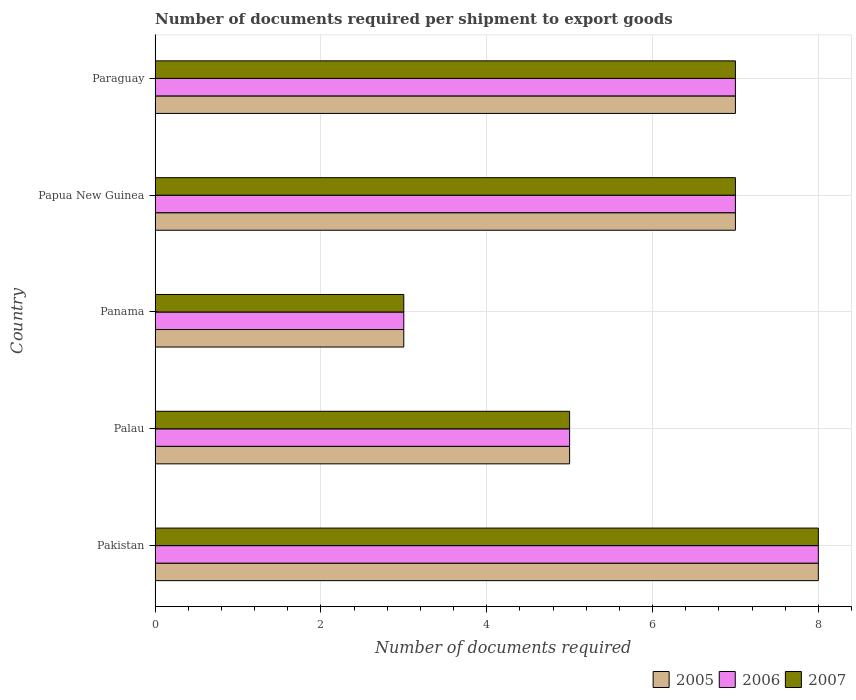How many groups of bars are there?
Your response must be concise. 5. Are the number of bars per tick equal to the number of legend labels?
Offer a very short reply. Yes. Are the number of bars on each tick of the Y-axis equal?
Your answer should be very brief. Yes. What is the label of the 1st group of bars from the top?
Make the answer very short. Paraguay. In how many cases, is the number of bars for a given country not equal to the number of legend labels?
Your answer should be very brief. 0. Across all countries, what is the maximum number of documents required per shipment to export goods in 2005?
Offer a terse response. 8. In which country was the number of documents required per shipment to export goods in 2006 minimum?
Give a very brief answer. Panama. What is the total number of documents required per shipment to export goods in 2005 in the graph?
Give a very brief answer. 30. What is the average number of documents required per shipment to export goods in 2006 per country?
Ensure brevity in your answer.  6. What is the difference between the number of documents required per shipment to export goods in 2005 and number of documents required per shipment to export goods in 2006 in Pakistan?
Make the answer very short. 0. In how many countries, is the number of documents required per shipment to export goods in 2007 greater than 6.8 ?
Offer a very short reply. 3. What is the ratio of the number of documents required per shipment to export goods in 2006 in Pakistan to that in Palau?
Your response must be concise. 1.6. Is the difference between the number of documents required per shipment to export goods in 2005 in Palau and Panama greater than the difference between the number of documents required per shipment to export goods in 2006 in Palau and Panama?
Keep it short and to the point. No. What is the difference between the highest and the second highest number of documents required per shipment to export goods in 2006?
Make the answer very short. 1. What is the difference between the highest and the lowest number of documents required per shipment to export goods in 2006?
Offer a terse response. 5. In how many countries, is the number of documents required per shipment to export goods in 2005 greater than the average number of documents required per shipment to export goods in 2005 taken over all countries?
Your answer should be compact. 3. Is the sum of the number of documents required per shipment to export goods in 2006 in Pakistan and Panama greater than the maximum number of documents required per shipment to export goods in 2007 across all countries?
Give a very brief answer. Yes. What does the 3rd bar from the top in Paraguay represents?
Ensure brevity in your answer.  2005. Is it the case that in every country, the sum of the number of documents required per shipment to export goods in 2005 and number of documents required per shipment to export goods in 2007 is greater than the number of documents required per shipment to export goods in 2006?
Provide a succinct answer. Yes. How many bars are there?
Your answer should be compact. 15. Are all the bars in the graph horizontal?
Your answer should be very brief. Yes. Does the graph contain grids?
Your answer should be compact. Yes. Where does the legend appear in the graph?
Your answer should be compact. Bottom right. What is the title of the graph?
Offer a terse response. Number of documents required per shipment to export goods. What is the label or title of the X-axis?
Your answer should be very brief. Number of documents required. What is the Number of documents required of 2006 in Palau?
Your answer should be very brief. 5. What is the Number of documents required in 2006 in Panama?
Your response must be concise. 3. What is the Number of documents required in 2006 in Papua New Guinea?
Your response must be concise. 7. Across all countries, what is the maximum Number of documents required of 2006?
Provide a short and direct response. 8. Across all countries, what is the maximum Number of documents required in 2007?
Ensure brevity in your answer.  8. What is the total Number of documents required of 2005 in the graph?
Give a very brief answer. 30. What is the total Number of documents required of 2006 in the graph?
Offer a very short reply. 30. What is the difference between the Number of documents required in 2005 in Pakistan and that in Palau?
Make the answer very short. 3. What is the difference between the Number of documents required in 2006 in Pakistan and that in Palau?
Offer a terse response. 3. What is the difference between the Number of documents required of 2007 in Pakistan and that in Palau?
Your answer should be very brief. 3. What is the difference between the Number of documents required of 2006 in Pakistan and that in Panama?
Offer a very short reply. 5. What is the difference between the Number of documents required of 2007 in Pakistan and that in Panama?
Provide a succinct answer. 5. What is the difference between the Number of documents required in 2005 in Pakistan and that in Papua New Guinea?
Offer a very short reply. 1. What is the difference between the Number of documents required of 2006 in Pakistan and that in Paraguay?
Your answer should be compact. 1. What is the difference between the Number of documents required in 2006 in Palau and that in Panama?
Keep it short and to the point. 2. What is the difference between the Number of documents required in 2005 in Palau and that in Papua New Guinea?
Provide a short and direct response. -2. What is the difference between the Number of documents required in 2006 in Palau and that in Papua New Guinea?
Offer a very short reply. -2. What is the difference between the Number of documents required of 2007 in Palau and that in Papua New Guinea?
Your answer should be very brief. -2. What is the difference between the Number of documents required of 2005 in Palau and that in Paraguay?
Offer a very short reply. -2. What is the difference between the Number of documents required in 2006 in Palau and that in Paraguay?
Make the answer very short. -2. What is the difference between the Number of documents required of 2007 in Palau and that in Paraguay?
Offer a very short reply. -2. What is the difference between the Number of documents required of 2006 in Panama and that in Papua New Guinea?
Keep it short and to the point. -4. What is the difference between the Number of documents required of 2005 in Panama and that in Paraguay?
Give a very brief answer. -4. What is the difference between the Number of documents required in 2006 in Panama and that in Paraguay?
Provide a succinct answer. -4. What is the difference between the Number of documents required in 2007 in Panama and that in Paraguay?
Provide a succinct answer. -4. What is the difference between the Number of documents required of 2005 in Papua New Guinea and that in Paraguay?
Ensure brevity in your answer.  0. What is the difference between the Number of documents required of 2006 in Papua New Guinea and that in Paraguay?
Offer a very short reply. 0. What is the difference between the Number of documents required in 2005 in Pakistan and the Number of documents required in 2007 in Panama?
Make the answer very short. 5. What is the difference between the Number of documents required of 2005 in Pakistan and the Number of documents required of 2007 in Papua New Guinea?
Offer a terse response. 1. What is the difference between the Number of documents required of 2006 in Pakistan and the Number of documents required of 2007 in Papua New Guinea?
Offer a very short reply. 1. What is the difference between the Number of documents required of 2005 in Pakistan and the Number of documents required of 2007 in Paraguay?
Your response must be concise. 1. What is the difference between the Number of documents required of 2005 in Palau and the Number of documents required of 2006 in Papua New Guinea?
Offer a very short reply. -2. What is the difference between the Number of documents required in 2006 in Palau and the Number of documents required in 2007 in Papua New Guinea?
Offer a very short reply. -2. What is the difference between the Number of documents required of 2005 in Panama and the Number of documents required of 2006 in Papua New Guinea?
Your response must be concise. -4. What is the difference between the Number of documents required of 2006 in Panama and the Number of documents required of 2007 in Papua New Guinea?
Provide a succinct answer. -4. What is the difference between the Number of documents required in 2005 in Panama and the Number of documents required in 2006 in Paraguay?
Make the answer very short. -4. What is the difference between the Number of documents required in 2005 in Panama and the Number of documents required in 2007 in Paraguay?
Provide a short and direct response. -4. What is the difference between the Number of documents required of 2005 in Papua New Guinea and the Number of documents required of 2007 in Paraguay?
Provide a short and direct response. 0. What is the average Number of documents required of 2005 per country?
Provide a succinct answer. 6. What is the average Number of documents required of 2006 per country?
Offer a terse response. 6. What is the average Number of documents required of 2007 per country?
Make the answer very short. 6. What is the difference between the Number of documents required of 2006 and Number of documents required of 2007 in Pakistan?
Ensure brevity in your answer.  0. What is the difference between the Number of documents required in 2005 and Number of documents required in 2006 in Palau?
Your response must be concise. 0. What is the difference between the Number of documents required of 2005 and Number of documents required of 2007 in Palau?
Your answer should be compact. 0. What is the difference between the Number of documents required of 2005 and Number of documents required of 2007 in Panama?
Your answer should be compact. 0. What is the difference between the Number of documents required of 2006 and Number of documents required of 2007 in Panama?
Ensure brevity in your answer.  0. What is the difference between the Number of documents required in 2005 and Number of documents required in 2007 in Papua New Guinea?
Keep it short and to the point. 0. What is the difference between the Number of documents required in 2006 and Number of documents required in 2007 in Papua New Guinea?
Keep it short and to the point. 0. What is the difference between the Number of documents required in 2006 and Number of documents required in 2007 in Paraguay?
Offer a very short reply. 0. What is the ratio of the Number of documents required in 2006 in Pakistan to that in Palau?
Offer a terse response. 1.6. What is the ratio of the Number of documents required in 2007 in Pakistan to that in Palau?
Provide a succinct answer. 1.6. What is the ratio of the Number of documents required in 2005 in Pakistan to that in Panama?
Your response must be concise. 2.67. What is the ratio of the Number of documents required in 2006 in Pakistan to that in Panama?
Offer a terse response. 2.67. What is the ratio of the Number of documents required in 2007 in Pakistan to that in Panama?
Keep it short and to the point. 2.67. What is the ratio of the Number of documents required of 2006 in Pakistan to that in Papua New Guinea?
Keep it short and to the point. 1.14. What is the ratio of the Number of documents required of 2007 in Pakistan to that in Papua New Guinea?
Offer a very short reply. 1.14. What is the ratio of the Number of documents required of 2006 in Pakistan to that in Paraguay?
Your response must be concise. 1.14. What is the ratio of the Number of documents required in 2007 in Pakistan to that in Paraguay?
Offer a terse response. 1.14. What is the ratio of the Number of documents required in 2005 in Palau to that in Panama?
Ensure brevity in your answer.  1.67. What is the ratio of the Number of documents required in 2006 in Palau to that in Panama?
Your response must be concise. 1.67. What is the ratio of the Number of documents required in 2007 in Palau to that in Panama?
Provide a short and direct response. 1.67. What is the ratio of the Number of documents required of 2005 in Palau to that in Papua New Guinea?
Provide a short and direct response. 0.71. What is the ratio of the Number of documents required of 2007 in Palau to that in Papua New Guinea?
Your answer should be very brief. 0.71. What is the ratio of the Number of documents required in 2006 in Palau to that in Paraguay?
Ensure brevity in your answer.  0.71. What is the ratio of the Number of documents required of 2007 in Palau to that in Paraguay?
Keep it short and to the point. 0.71. What is the ratio of the Number of documents required in 2005 in Panama to that in Papua New Guinea?
Your response must be concise. 0.43. What is the ratio of the Number of documents required of 2006 in Panama to that in Papua New Guinea?
Offer a terse response. 0.43. What is the ratio of the Number of documents required in 2007 in Panama to that in Papua New Guinea?
Offer a very short reply. 0.43. What is the ratio of the Number of documents required in 2005 in Panama to that in Paraguay?
Provide a short and direct response. 0.43. What is the ratio of the Number of documents required in 2006 in Panama to that in Paraguay?
Provide a short and direct response. 0.43. What is the ratio of the Number of documents required of 2007 in Panama to that in Paraguay?
Provide a succinct answer. 0.43. What is the ratio of the Number of documents required of 2006 in Papua New Guinea to that in Paraguay?
Offer a terse response. 1. What is the difference between the highest and the second highest Number of documents required of 2005?
Your answer should be very brief. 1. What is the difference between the highest and the second highest Number of documents required of 2006?
Offer a very short reply. 1. What is the difference between the highest and the lowest Number of documents required of 2007?
Provide a short and direct response. 5. 